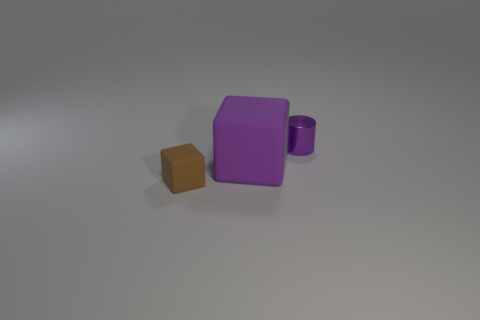What is the purple cube made of?
Offer a very short reply. Rubber. What is the size of the purple cylinder that is to the right of the brown rubber cube?
Make the answer very short. Small. Is there anything else that is the same color as the tiny rubber object?
Offer a very short reply. No. There is a rubber block that is behind the small thing that is left of the big purple block; are there any tiny brown objects to the left of it?
Your response must be concise. Yes. There is a cube right of the brown object; does it have the same color as the tiny cylinder?
Keep it short and to the point. Yes. What number of blocks are either big purple matte things or rubber things?
Your answer should be compact. 2. What shape is the purple object on the left side of the small shiny thing right of the brown matte cube?
Offer a very short reply. Cube. What is the size of the purple object that is to the left of the object behind the matte block that is behind the brown cube?
Your response must be concise. Large. Does the brown object have the same size as the metallic cylinder?
Your response must be concise. Yes. How many things are large purple rubber blocks or large yellow shiny objects?
Ensure brevity in your answer.  1. 